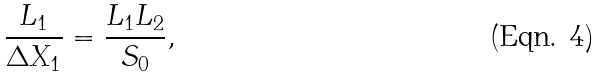Convert formula to latex. <formula><loc_0><loc_0><loc_500><loc_500>\frac { L _ { 1 } } { \Delta X _ { 1 } } = \frac { L _ { 1 } L _ { 2 } } { S _ { 0 } } ,</formula> 